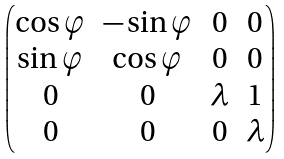Convert formula to latex. <formula><loc_0><loc_0><loc_500><loc_500>\begin{pmatrix} \cos \varphi & - \sin \varphi & 0 & 0 \\ \sin \varphi & \cos \varphi & 0 & 0 \\ 0 & 0 & \lambda & 1 \\ 0 & 0 & 0 & \lambda \end{pmatrix}</formula> 